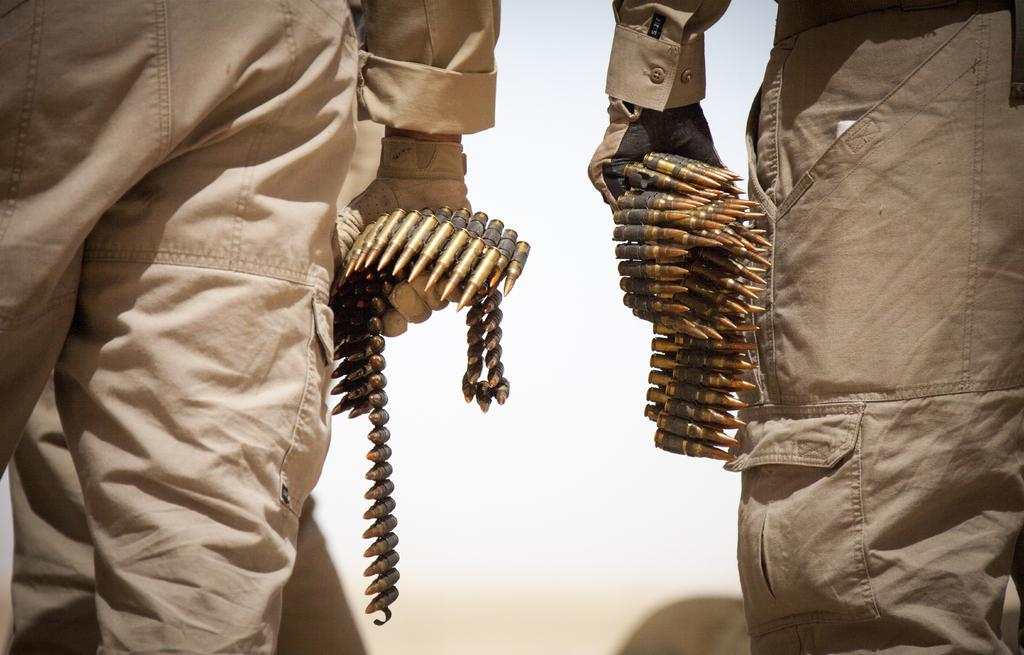How many people are in the image? There are two persons in the image. What are the two persons holding in the image? The two persons are holding a strip of bullets. Where is the library located in the image? There is no library present in the image. Are the two persons swimming in the image? There is no indication of swimming or water in the image; the two persons are holding a strip of bullets. 